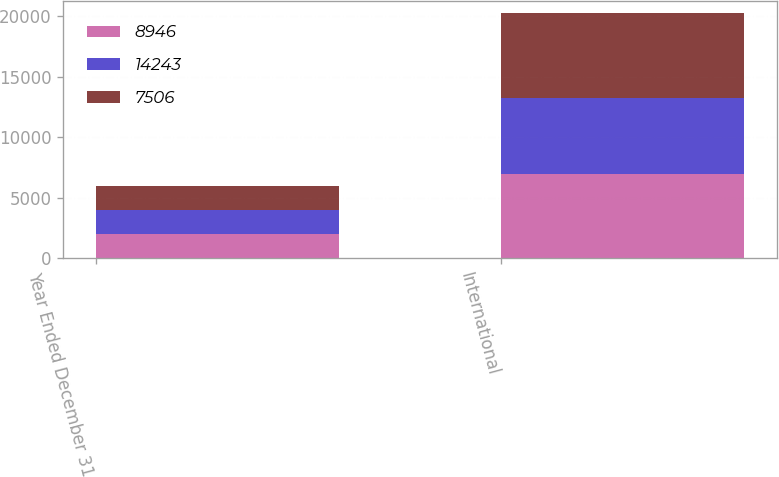Convert chart to OTSL. <chart><loc_0><loc_0><loc_500><loc_500><stacked_bar_chart><ecel><fcel>Year Ended December 31<fcel>International<nl><fcel>8946<fcel>2010<fcel>7019<nl><fcel>14243<fcel>2009<fcel>6255<nl><fcel>7506<fcel>2008<fcel>6987<nl></chart> 